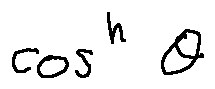Convert formula to latex. <formula><loc_0><loc_0><loc_500><loc_500>\cos ^ { n } \theta</formula> 